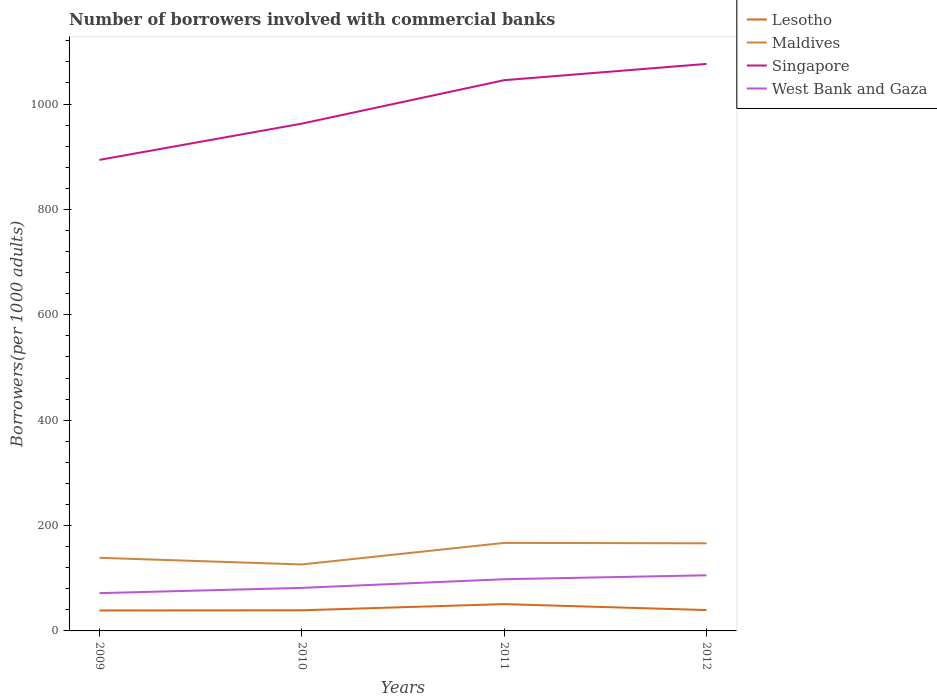How many different coloured lines are there?
Make the answer very short. 4. Is the number of lines equal to the number of legend labels?
Make the answer very short. Yes. Across all years, what is the maximum number of borrowers involved with commercial banks in Maldives?
Your answer should be very brief. 126.14. What is the total number of borrowers involved with commercial banks in Lesotho in the graph?
Ensure brevity in your answer.  -0.47. What is the difference between the highest and the second highest number of borrowers involved with commercial banks in West Bank and Gaza?
Offer a terse response. 33.89. Is the number of borrowers involved with commercial banks in Singapore strictly greater than the number of borrowers involved with commercial banks in Lesotho over the years?
Make the answer very short. No. How many lines are there?
Provide a succinct answer. 4. How many years are there in the graph?
Offer a very short reply. 4. Are the values on the major ticks of Y-axis written in scientific E-notation?
Ensure brevity in your answer.  No. Does the graph contain grids?
Offer a terse response. No. Where does the legend appear in the graph?
Offer a terse response. Top right. How many legend labels are there?
Offer a terse response. 4. How are the legend labels stacked?
Ensure brevity in your answer.  Vertical. What is the title of the graph?
Provide a succinct answer. Number of borrowers involved with commercial banks. Does "Eritrea" appear as one of the legend labels in the graph?
Offer a terse response. No. What is the label or title of the Y-axis?
Offer a terse response. Borrowers(per 1000 adults). What is the Borrowers(per 1000 adults) in Lesotho in 2009?
Keep it short and to the point. 38.81. What is the Borrowers(per 1000 adults) of Maldives in 2009?
Your answer should be very brief. 138.77. What is the Borrowers(per 1000 adults) in Singapore in 2009?
Your response must be concise. 894.01. What is the Borrowers(per 1000 adults) of West Bank and Gaza in 2009?
Provide a succinct answer. 71.69. What is the Borrowers(per 1000 adults) in Lesotho in 2010?
Provide a short and direct response. 39.16. What is the Borrowers(per 1000 adults) of Maldives in 2010?
Provide a short and direct response. 126.14. What is the Borrowers(per 1000 adults) of Singapore in 2010?
Offer a terse response. 962.8. What is the Borrowers(per 1000 adults) in West Bank and Gaza in 2010?
Provide a succinct answer. 81.68. What is the Borrowers(per 1000 adults) in Lesotho in 2011?
Your answer should be compact. 50.87. What is the Borrowers(per 1000 adults) of Maldives in 2011?
Your response must be concise. 167.07. What is the Borrowers(per 1000 adults) of Singapore in 2011?
Offer a terse response. 1045.25. What is the Borrowers(per 1000 adults) in West Bank and Gaza in 2011?
Give a very brief answer. 98.13. What is the Borrowers(per 1000 adults) of Lesotho in 2012?
Offer a terse response. 39.63. What is the Borrowers(per 1000 adults) of Maldives in 2012?
Give a very brief answer. 166.29. What is the Borrowers(per 1000 adults) of Singapore in 2012?
Ensure brevity in your answer.  1076.16. What is the Borrowers(per 1000 adults) of West Bank and Gaza in 2012?
Offer a very short reply. 105.58. Across all years, what is the maximum Borrowers(per 1000 adults) in Lesotho?
Ensure brevity in your answer.  50.87. Across all years, what is the maximum Borrowers(per 1000 adults) in Maldives?
Give a very brief answer. 167.07. Across all years, what is the maximum Borrowers(per 1000 adults) of Singapore?
Your answer should be compact. 1076.16. Across all years, what is the maximum Borrowers(per 1000 adults) of West Bank and Gaza?
Give a very brief answer. 105.58. Across all years, what is the minimum Borrowers(per 1000 adults) in Lesotho?
Keep it short and to the point. 38.81. Across all years, what is the minimum Borrowers(per 1000 adults) of Maldives?
Give a very brief answer. 126.14. Across all years, what is the minimum Borrowers(per 1000 adults) in Singapore?
Provide a succinct answer. 894.01. Across all years, what is the minimum Borrowers(per 1000 adults) in West Bank and Gaza?
Make the answer very short. 71.69. What is the total Borrowers(per 1000 adults) of Lesotho in the graph?
Your answer should be compact. 168.48. What is the total Borrowers(per 1000 adults) of Maldives in the graph?
Ensure brevity in your answer.  598.26. What is the total Borrowers(per 1000 adults) in Singapore in the graph?
Keep it short and to the point. 3978.22. What is the total Borrowers(per 1000 adults) in West Bank and Gaza in the graph?
Your answer should be very brief. 357.09. What is the difference between the Borrowers(per 1000 adults) of Lesotho in 2009 and that in 2010?
Your response must be concise. -0.35. What is the difference between the Borrowers(per 1000 adults) in Maldives in 2009 and that in 2010?
Ensure brevity in your answer.  12.63. What is the difference between the Borrowers(per 1000 adults) in Singapore in 2009 and that in 2010?
Provide a short and direct response. -68.78. What is the difference between the Borrowers(per 1000 adults) in West Bank and Gaza in 2009 and that in 2010?
Your response must be concise. -9.99. What is the difference between the Borrowers(per 1000 adults) of Lesotho in 2009 and that in 2011?
Offer a terse response. -12.06. What is the difference between the Borrowers(per 1000 adults) in Maldives in 2009 and that in 2011?
Your answer should be very brief. -28.3. What is the difference between the Borrowers(per 1000 adults) of Singapore in 2009 and that in 2011?
Keep it short and to the point. -151.24. What is the difference between the Borrowers(per 1000 adults) in West Bank and Gaza in 2009 and that in 2011?
Offer a very short reply. -26.44. What is the difference between the Borrowers(per 1000 adults) in Lesotho in 2009 and that in 2012?
Ensure brevity in your answer.  -0.82. What is the difference between the Borrowers(per 1000 adults) in Maldives in 2009 and that in 2012?
Your answer should be very brief. -27.52. What is the difference between the Borrowers(per 1000 adults) in Singapore in 2009 and that in 2012?
Offer a terse response. -182.15. What is the difference between the Borrowers(per 1000 adults) in West Bank and Gaza in 2009 and that in 2012?
Ensure brevity in your answer.  -33.89. What is the difference between the Borrowers(per 1000 adults) of Lesotho in 2010 and that in 2011?
Your answer should be compact. -11.71. What is the difference between the Borrowers(per 1000 adults) in Maldives in 2010 and that in 2011?
Your response must be concise. -40.93. What is the difference between the Borrowers(per 1000 adults) in Singapore in 2010 and that in 2011?
Provide a short and direct response. -82.46. What is the difference between the Borrowers(per 1000 adults) of West Bank and Gaza in 2010 and that in 2011?
Provide a short and direct response. -16.45. What is the difference between the Borrowers(per 1000 adults) of Lesotho in 2010 and that in 2012?
Offer a very short reply. -0.47. What is the difference between the Borrowers(per 1000 adults) of Maldives in 2010 and that in 2012?
Keep it short and to the point. -40.15. What is the difference between the Borrowers(per 1000 adults) in Singapore in 2010 and that in 2012?
Your response must be concise. -113.36. What is the difference between the Borrowers(per 1000 adults) in West Bank and Gaza in 2010 and that in 2012?
Make the answer very short. -23.89. What is the difference between the Borrowers(per 1000 adults) in Lesotho in 2011 and that in 2012?
Make the answer very short. 11.24. What is the difference between the Borrowers(per 1000 adults) of Maldives in 2011 and that in 2012?
Give a very brief answer. 0.78. What is the difference between the Borrowers(per 1000 adults) of Singapore in 2011 and that in 2012?
Provide a short and direct response. -30.9. What is the difference between the Borrowers(per 1000 adults) of West Bank and Gaza in 2011 and that in 2012?
Keep it short and to the point. -7.44. What is the difference between the Borrowers(per 1000 adults) of Lesotho in 2009 and the Borrowers(per 1000 adults) of Maldives in 2010?
Make the answer very short. -87.33. What is the difference between the Borrowers(per 1000 adults) of Lesotho in 2009 and the Borrowers(per 1000 adults) of Singapore in 2010?
Offer a terse response. -923.99. What is the difference between the Borrowers(per 1000 adults) in Lesotho in 2009 and the Borrowers(per 1000 adults) in West Bank and Gaza in 2010?
Ensure brevity in your answer.  -42.87. What is the difference between the Borrowers(per 1000 adults) in Maldives in 2009 and the Borrowers(per 1000 adults) in Singapore in 2010?
Provide a short and direct response. -824.03. What is the difference between the Borrowers(per 1000 adults) of Maldives in 2009 and the Borrowers(per 1000 adults) of West Bank and Gaza in 2010?
Ensure brevity in your answer.  57.08. What is the difference between the Borrowers(per 1000 adults) in Singapore in 2009 and the Borrowers(per 1000 adults) in West Bank and Gaza in 2010?
Provide a short and direct response. 812.33. What is the difference between the Borrowers(per 1000 adults) of Lesotho in 2009 and the Borrowers(per 1000 adults) of Maldives in 2011?
Provide a short and direct response. -128.26. What is the difference between the Borrowers(per 1000 adults) of Lesotho in 2009 and the Borrowers(per 1000 adults) of Singapore in 2011?
Give a very brief answer. -1006.44. What is the difference between the Borrowers(per 1000 adults) in Lesotho in 2009 and the Borrowers(per 1000 adults) in West Bank and Gaza in 2011?
Make the answer very short. -59.33. What is the difference between the Borrowers(per 1000 adults) of Maldives in 2009 and the Borrowers(per 1000 adults) of Singapore in 2011?
Your response must be concise. -906.48. What is the difference between the Borrowers(per 1000 adults) in Maldives in 2009 and the Borrowers(per 1000 adults) in West Bank and Gaza in 2011?
Ensure brevity in your answer.  40.63. What is the difference between the Borrowers(per 1000 adults) of Singapore in 2009 and the Borrowers(per 1000 adults) of West Bank and Gaza in 2011?
Provide a short and direct response. 795.88. What is the difference between the Borrowers(per 1000 adults) in Lesotho in 2009 and the Borrowers(per 1000 adults) in Maldives in 2012?
Your answer should be compact. -127.48. What is the difference between the Borrowers(per 1000 adults) of Lesotho in 2009 and the Borrowers(per 1000 adults) of Singapore in 2012?
Give a very brief answer. -1037.35. What is the difference between the Borrowers(per 1000 adults) of Lesotho in 2009 and the Borrowers(per 1000 adults) of West Bank and Gaza in 2012?
Your response must be concise. -66.77. What is the difference between the Borrowers(per 1000 adults) in Maldives in 2009 and the Borrowers(per 1000 adults) in Singapore in 2012?
Your answer should be compact. -937.39. What is the difference between the Borrowers(per 1000 adults) in Maldives in 2009 and the Borrowers(per 1000 adults) in West Bank and Gaza in 2012?
Offer a very short reply. 33.19. What is the difference between the Borrowers(per 1000 adults) in Singapore in 2009 and the Borrowers(per 1000 adults) in West Bank and Gaza in 2012?
Offer a very short reply. 788.43. What is the difference between the Borrowers(per 1000 adults) of Lesotho in 2010 and the Borrowers(per 1000 adults) of Maldives in 2011?
Your response must be concise. -127.91. What is the difference between the Borrowers(per 1000 adults) in Lesotho in 2010 and the Borrowers(per 1000 adults) in Singapore in 2011?
Provide a succinct answer. -1006.09. What is the difference between the Borrowers(per 1000 adults) in Lesotho in 2010 and the Borrowers(per 1000 adults) in West Bank and Gaza in 2011?
Your response must be concise. -58.97. What is the difference between the Borrowers(per 1000 adults) in Maldives in 2010 and the Borrowers(per 1000 adults) in Singapore in 2011?
Give a very brief answer. -919.11. What is the difference between the Borrowers(per 1000 adults) in Maldives in 2010 and the Borrowers(per 1000 adults) in West Bank and Gaza in 2011?
Provide a succinct answer. 28. What is the difference between the Borrowers(per 1000 adults) of Singapore in 2010 and the Borrowers(per 1000 adults) of West Bank and Gaza in 2011?
Provide a succinct answer. 864.66. What is the difference between the Borrowers(per 1000 adults) of Lesotho in 2010 and the Borrowers(per 1000 adults) of Maldives in 2012?
Provide a succinct answer. -127.13. What is the difference between the Borrowers(per 1000 adults) of Lesotho in 2010 and the Borrowers(per 1000 adults) of Singapore in 2012?
Give a very brief answer. -1037. What is the difference between the Borrowers(per 1000 adults) of Lesotho in 2010 and the Borrowers(per 1000 adults) of West Bank and Gaza in 2012?
Ensure brevity in your answer.  -66.42. What is the difference between the Borrowers(per 1000 adults) of Maldives in 2010 and the Borrowers(per 1000 adults) of Singapore in 2012?
Provide a short and direct response. -950.02. What is the difference between the Borrowers(per 1000 adults) of Maldives in 2010 and the Borrowers(per 1000 adults) of West Bank and Gaza in 2012?
Your response must be concise. 20.56. What is the difference between the Borrowers(per 1000 adults) in Singapore in 2010 and the Borrowers(per 1000 adults) in West Bank and Gaza in 2012?
Your answer should be very brief. 857.22. What is the difference between the Borrowers(per 1000 adults) of Lesotho in 2011 and the Borrowers(per 1000 adults) of Maldives in 2012?
Provide a short and direct response. -115.42. What is the difference between the Borrowers(per 1000 adults) in Lesotho in 2011 and the Borrowers(per 1000 adults) in Singapore in 2012?
Make the answer very short. -1025.29. What is the difference between the Borrowers(per 1000 adults) of Lesotho in 2011 and the Borrowers(per 1000 adults) of West Bank and Gaza in 2012?
Offer a terse response. -54.71. What is the difference between the Borrowers(per 1000 adults) of Maldives in 2011 and the Borrowers(per 1000 adults) of Singapore in 2012?
Give a very brief answer. -909.09. What is the difference between the Borrowers(per 1000 adults) of Maldives in 2011 and the Borrowers(per 1000 adults) of West Bank and Gaza in 2012?
Your response must be concise. 61.49. What is the difference between the Borrowers(per 1000 adults) of Singapore in 2011 and the Borrowers(per 1000 adults) of West Bank and Gaza in 2012?
Make the answer very short. 939.67. What is the average Borrowers(per 1000 adults) of Lesotho per year?
Ensure brevity in your answer.  42.12. What is the average Borrowers(per 1000 adults) in Maldives per year?
Your answer should be compact. 149.57. What is the average Borrowers(per 1000 adults) in Singapore per year?
Provide a short and direct response. 994.55. What is the average Borrowers(per 1000 adults) in West Bank and Gaza per year?
Make the answer very short. 89.27. In the year 2009, what is the difference between the Borrowers(per 1000 adults) of Lesotho and Borrowers(per 1000 adults) of Maldives?
Ensure brevity in your answer.  -99.96. In the year 2009, what is the difference between the Borrowers(per 1000 adults) in Lesotho and Borrowers(per 1000 adults) in Singapore?
Your response must be concise. -855.2. In the year 2009, what is the difference between the Borrowers(per 1000 adults) in Lesotho and Borrowers(per 1000 adults) in West Bank and Gaza?
Make the answer very short. -32.88. In the year 2009, what is the difference between the Borrowers(per 1000 adults) of Maldives and Borrowers(per 1000 adults) of Singapore?
Your answer should be compact. -755.24. In the year 2009, what is the difference between the Borrowers(per 1000 adults) in Maldives and Borrowers(per 1000 adults) in West Bank and Gaza?
Your answer should be very brief. 67.08. In the year 2009, what is the difference between the Borrowers(per 1000 adults) of Singapore and Borrowers(per 1000 adults) of West Bank and Gaza?
Provide a succinct answer. 822.32. In the year 2010, what is the difference between the Borrowers(per 1000 adults) in Lesotho and Borrowers(per 1000 adults) in Maldives?
Ensure brevity in your answer.  -86.98. In the year 2010, what is the difference between the Borrowers(per 1000 adults) of Lesotho and Borrowers(per 1000 adults) of Singapore?
Offer a very short reply. -923.64. In the year 2010, what is the difference between the Borrowers(per 1000 adults) of Lesotho and Borrowers(per 1000 adults) of West Bank and Gaza?
Keep it short and to the point. -42.52. In the year 2010, what is the difference between the Borrowers(per 1000 adults) in Maldives and Borrowers(per 1000 adults) in Singapore?
Offer a very short reply. -836.66. In the year 2010, what is the difference between the Borrowers(per 1000 adults) of Maldives and Borrowers(per 1000 adults) of West Bank and Gaza?
Offer a terse response. 44.45. In the year 2010, what is the difference between the Borrowers(per 1000 adults) of Singapore and Borrowers(per 1000 adults) of West Bank and Gaza?
Offer a terse response. 881.11. In the year 2011, what is the difference between the Borrowers(per 1000 adults) in Lesotho and Borrowers(per 1000 adults) in Maldives?
Make the answer very short. -116.19. In the year 2011, what is the difference between the Borrowers(per 1000 adults) in Lesotho and Borrowers(per 1000 adults) in Singapore?
Provide a succinct answer. -994.38. In the year 2011, what is the difference between the Borrowers(per 1000 adults) of Lesotho and Borrowers(per 1000 adults) of West Bank and Gaza?
Ensure brevity in your answer.  -47.26. In the year 2011, what is the difference between the Borrowers(per 1000 adults) in Maldives and Borrowers(per 1000 adults) in Singapore?
Provide a short and direct response. -878.19. In the year 2011, what is the difference between the Borrowers(per 1000 adults) in Maldives and Borrowers(per 1000 adults) in West Bank and Gaza?
Offer a terse response. 68.93. In the year 2011, what is the difference between the Borrowers(per 1000 adults) in Singapore and Borrowers(per 1000 adults) in West Bank and Gaza?
Provide a succinct answer. 947.12. In the year 2012, what is the difference between the Borrowers(per 1000 adults) of Lesotho and Borrowers(per 1000 adults) of Maldives?
Make the answer very short. -126.66. In the year 2012, what is the difference between the Borrowers(per 1000 adults) in Lesotho and Borrowers(per 1000 adults) in Singapore?
Ensure brevity in your answer.  -1036.52. In the year 2012, what is the difference between the Borrowers(per 1000 adults) in Lesotho and Borrowers(per 1000 adults) in West Bank and Gaza?
Make the answer very short. -65.95. In the year 2012, what is the difference between the Borrowers(per 1000 adults) in Maldives and Borrowers(per 1000 adults) in Singapore?
Give a very brief answer. -909.87. In the year 2012, what is the difference between the Borrowers(per 1000 adults) of Maldives and Borrowers(per 1000 adults) of West Bank and Gaza?
Keep it short and to the point. 60.71. In the year 2012, what is the difference between the Borrowers(per 1000 adults) in Singapore and Borrowers(per 1000 adults) in West Bank and Gaza?
Offer a terse response. 970.58. What is the ratio of the Borrowers(per 1000 adults) in Lesotho in 2009 to that in 2010?
Make the answer very short. 0.99. What is the ratio of the Borrowers(per 1000 adults) in Maldives in 2009 to that in 2010?
Your answer should be very brief. 1.1. What is the ratio of the Borrowers(per 1000 adults) in West Bank and Gaza in 2009 to that in 2010?
Your answer should be very brief. 0.88. What is the ratio of the Borrowers(per 1000 adults) in Lesotho in 2009 to that in 2011?
Give a very brief answer. 0.76. What is the ratio of the Borrowers(per 1000 adults) of Maldives in 2009 to that in 2011?
Ensure brevity in your answer.  0.83. What is the ratio of the Borrowers(per 1000 adults) of Singapore in 2009 to that in 2011?
Keep it short and to the point. 0.86. What is the ratio of the Borrowers(per 1000 adults) in West Bank and Gaza in 2009 to that in 2011?
Give a very brief answer. 0.73. What is the ratio of the Borrowers(per 1000 adults) in Lesotho in 2009 to that in 2012?
Make the answer very short. 0.98. What is the ratio of the Borrowers(per 1000 adults) in Maldives in 2009 to that in 2012?
Provide a short and direct response. 0.83. What is the ratio of the Borrowers(per 1000 adults) in Singapore in 2009 to that in 2012?
Your answer should be compact. 0.83. What is the ratio of the Borrowers(per 1000 adults) of West Bank and Gaza in 2009 to that in 2012?
Provide a short and direct response. 0.68. What is the ratio of the Borrowers(per 1000 adults) in Lesotho in 2010 to that in 2011?
Your response must be concise. 0.77. What is the ratio of the Borrowers(per 1000 adults) of Maldives in 2010 to that in 2011?
Offer a very short reply. 0.76. What is the ratio of the Borrowers(per 1000 adults) in Singapore in 2010 to that in 2011?
Give a very brief answer. 0.92. What is the ratio of the Borrowers(per 1000 adults) of West Bank and Gaza in 2010 to that in 2011?
Provide a succinct answer. 0.83. What is the ratio of the Borrowers(per 1000 adults) in Lesotho in 2010 to that in 2012?
Your response must be concise. 0.99. What is the ratio of the Borrowers(per 1000 adults) of Maldives in 2010 to that in 2012?
Your answer should be compact. 0.76. What is the ratio of the Borrowers(per 1000 adults) in Singapore in 2010 to that in 2012?
Your answer should be very brief. 0.89. What is the ratio of the Borrowers(per 1000 adults) of West Bank and Gaza in 2010 to that in 2012?
Make the answer very short. 0.77. What is the ratio of the Borrowers(per 1000 adults) in Lesotho in 2011 to that in 2012?
Make the answer very short. 1.28. What is the ratio of the Borrowers(per 1000 adults) of Maldives in 2011 to that in 2012?
Your response must be concise. 1. What is the ratio of the Borrowers(per 1000 adults) of Singapore in 2011 to that in 2012?
Ensure brevity in your answer.  0.97. What is the ratio of the Borrowers(per 1000 adults) of West Bank and Gaza in 2011 to that in 2012?
Offer a very short reply. 0.93. What is the difference between the highest and the second highest Borrowers(per 1000 adults) of Lesotho?
Give a very brief answer. 11.24. What is the difference between the highest and the second highest Borrowers(per 1000 adults) in Maldives?
Offer a terse response. 0.78. What is the difference between the highest and the second highest Borrowers(per 1000 adults) in Singapore?
Make the answer very short. 30.9. What is the difference between the highest and the second highest Borrowers(per 1000 adults) of West Bank and Gaza?
Offer a very short reply. 7.44. What is the difference between the highest and the lowest Borrowers(per 1000 adults) in Lesotho?
Provide a short and direct response. 12.06. What is the difference between the highest and the lowest Borrowers(per 1000 adults) of Maldives?
Ensure brevity in your answer.  40.93. What is the difference between the highest and the lowest Borrowers(per 1000 adults) in Singapore?
Offer a very short reply. 182.15. What is the difference between the highest and the lowest Borrowers(per 1000 adults) in West Bank and Gaza?
Your answer should be very brief. 33.89. 